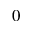Convert formula to latex. <formula><loc_0><loc_0><loc_500><loc_500>0</formula> 